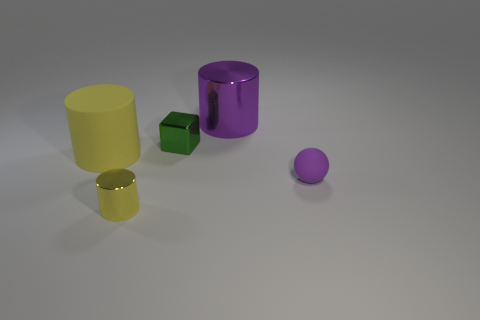Is there anything else that has the same shape as the tiny matte object?
Ensure brevity in your answer.  No. How many small blue rubber cylinders are there?
Your answer should be compact. 0. What number of big yellow things are made of the same material as the small cube?
Your response must be concise. 0. Are there the same number of large purple cylinders to the left of the tiny green metal object and big cyan rubber cubes?
Keep it short and to the point. Yes. What is the material of the ball that is the same color as the big metallic cylinder?
Provide a short and direct response. Rubber. Does the yellow shiny cylinder have the same size as the matte thing that is to the right of the small cylinder?
Your answer should be very brief. Yes. What number of other objects are there of the same size as the matte ball?
Make the answer very short. 2. What number of other objects are there of the same color as the tiny cylinder?
Your answer should be compact. 1. How many other things are there of the same shape as the small yellow object?
Your answer should be very brief. 2. Does the yellow shiny thing have the same size as the purple cylinder?
Your response must be concise. No. 